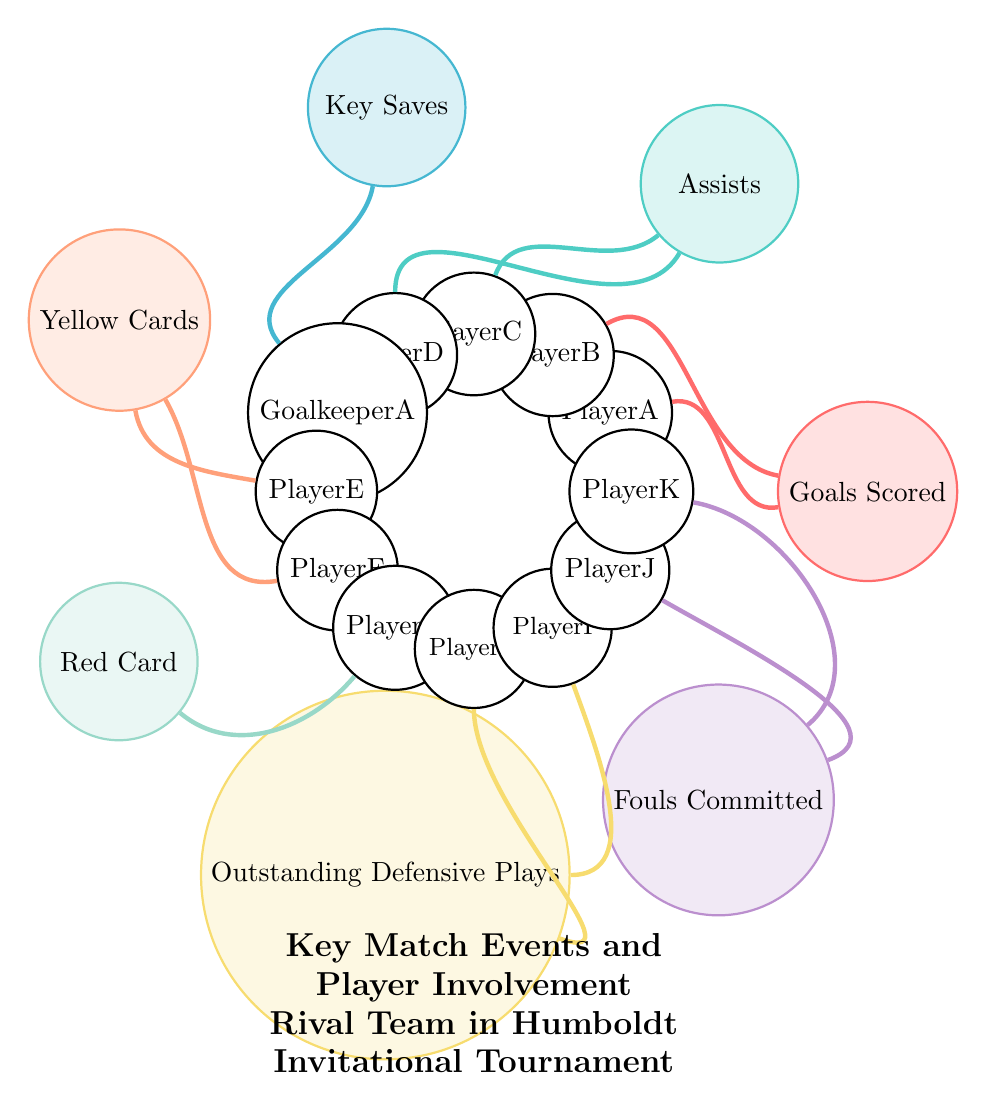What events involved PlayerA? PlayerA is involved in "Goals Scored" and not listed in other events, so we only consider the single connection shown in the diagram.
Answer: Goals Scored How many players were involved in the "Assists" event? The "Assists" event has connections to two players, PlayerC and PlayerD, as indicated by the two connections drawn from the "Assists" node.
Answer: 2 Which player received a Red Card? The "Red Card" event has one player, PlayerG, directly connected to it as shown in the diagram.
Answer: PlayerG What are the total types of key match events represented? By counting the labeled events in the diagram, we see there are seven unique types clearly labeled around the central diagram.
Answer: 7 Which player was involved in Key Saves? The "Key Saves" event connects to one player, specifically showing the link to GoalkeeperA, who is noted as the player for this event.
Answer: GoalkeeperA What color represents the "Fouls Committed" event? The color assigned to "Fouls Committed" is shown as color7, which is drawn in a thick dark line connecting to both PlayerJ and PlayerK.
Answer: color7 Are there any events that involve more than two players? Upon examining the connections, the "Goals Scored," "Assists," and "Key Saves" events all involve either one or two players, but none exceed this count. Hence, the answer is based on counting connections per event.
Answer: No Which event is associated with the highest number of players? Each event is inspected: "Goals Scored" has 2, "Assists" has 2, "Key Saves" has 1, "Yellow Cards" has 2, "Red Card" has 1, "Outstanding Defensive Plays" has 2, and "Fouls Committed" has 2. All events have a maximum of 2 players, indicating there isn't a single event with a higher number.
Answer: None 